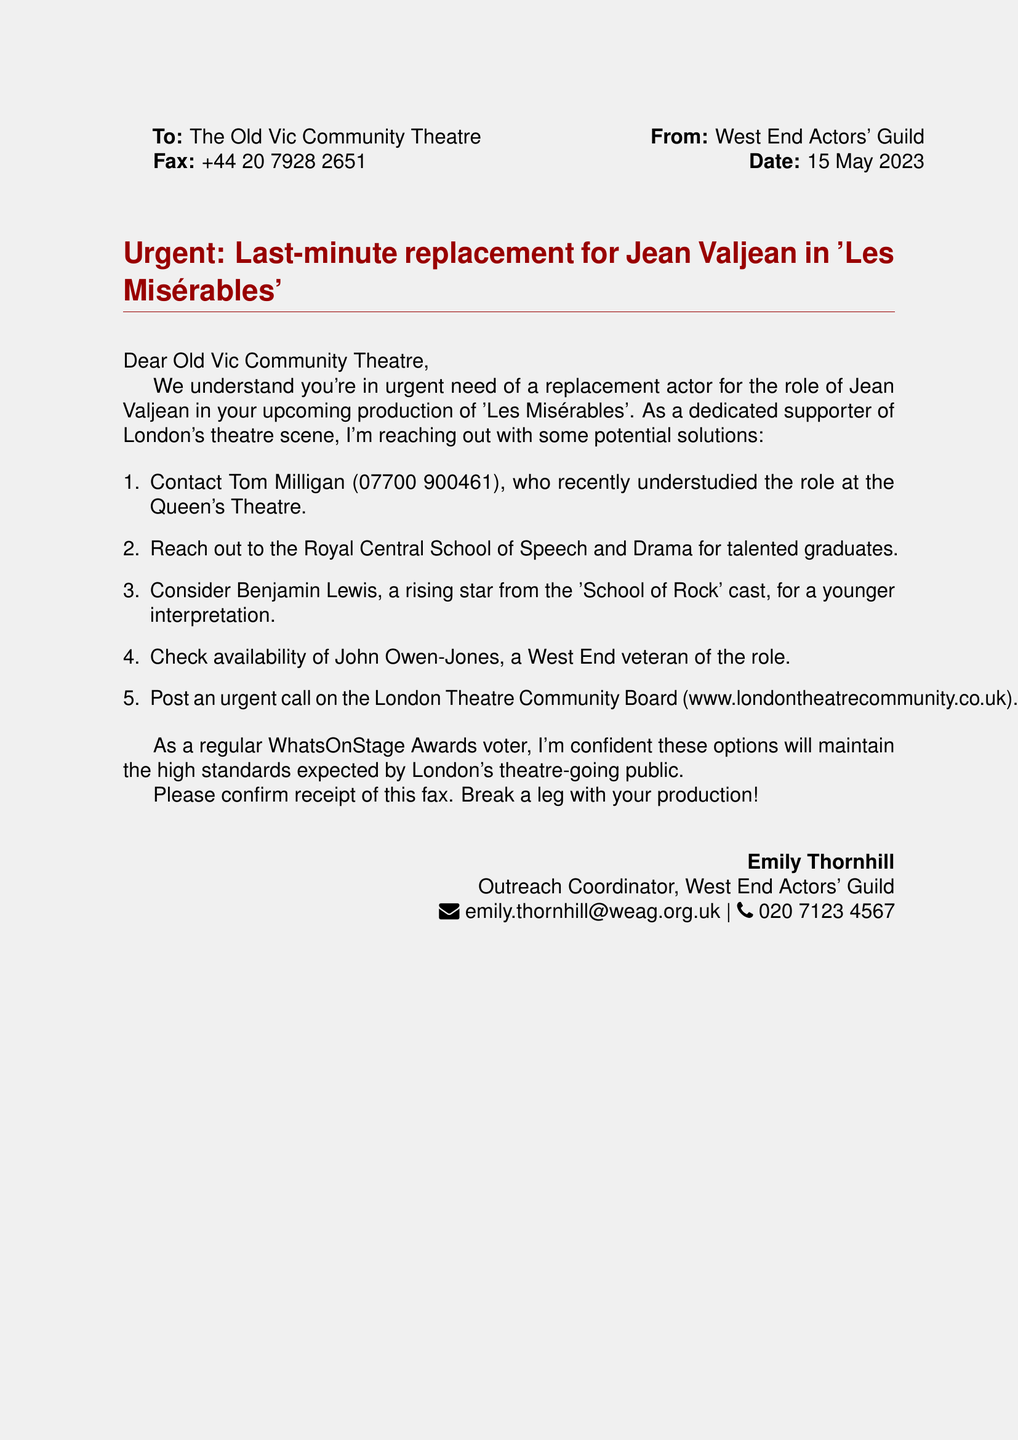What is the date of the fax? The date is mentioned in the header of the fax.
Answer: 15 May 2023 Who is the sender of the fax? The sender's information is noted at the bottom of the fax.
Answer: Emily Thornhill What role needs a last-minute replacement? The specific role for which a replacement is needed is stated in the subject line of the fax.
Answer: Jean Valjean Which theatre is mentioned in the fax? The name of the theatre is also included in the header.
Answer: The Old Vic Community Theatre Who can be contacted as a potential replacement? The fax lists a person who can be contacted for the role.
Answer: Tom Milligan What is the phone number for the sender? The sender's contact information includes a phone number.
Answer: 020 7123 4567 What website is suggested for posting an urgent call? The website is listed in the suggestions for finding a replacement actor.
Answer: www.londontheatrecommunity.co.uk How many potential replacement actors are suggested? The number of suggestions is indicated in the enumerated list.
Answer: Five 